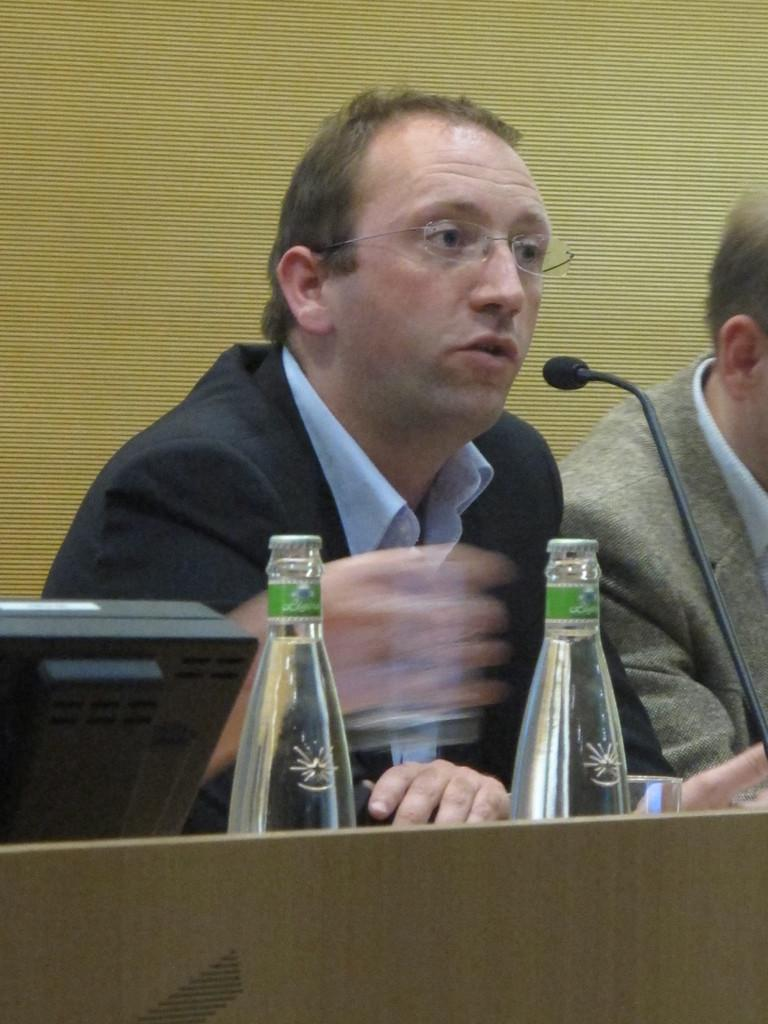How many people are in the image? There are two persons in the image. What can be observed about one of the persons? One person is wearing spectacles. What is the person wearing spectacles wearing? The person with spectacles is wearing a black suit. What other objects are present in the image? There are two bottles and a microphone (mike) in the image. What type of carpentry tools can be seen in the image? There are no carpentry tools present in the image. Is there a basin visible in the image? No, there is no basin visible in the image. 